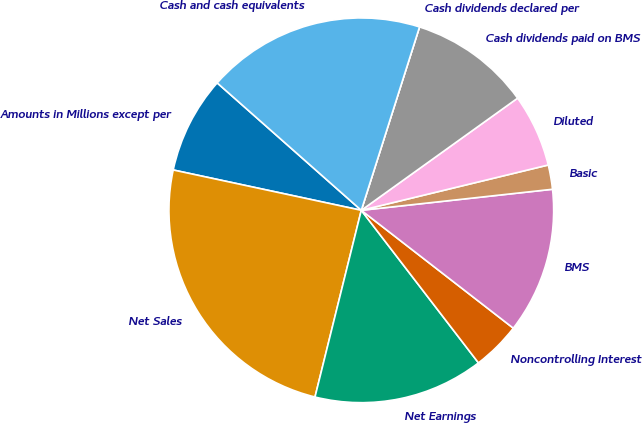Convert chart to OTSL. <chart><loc_0><loc_0><loc_500><loc_500><pie_chart><fcel>Amounts in Millions except per<fcel>Net Sales<fcel>Net Earnings<fcel>Noncontrolling Interest<fcel>BMS<fcel>Basic<fcel>Diluted<fcel>Cash dividends paid on BMS<fcel>Cash dividends declared per<fcel>Cash and cash equivalents<nl><fcel>8.16%<fcel>24.49%<fcel>14.29%<fcel>4.08%<fcel>12.24%<fcel>2.04%<fcel>6.12%<fcel>10.2%<fcel>0.0%<fcel>18.37%<nl></chart> 